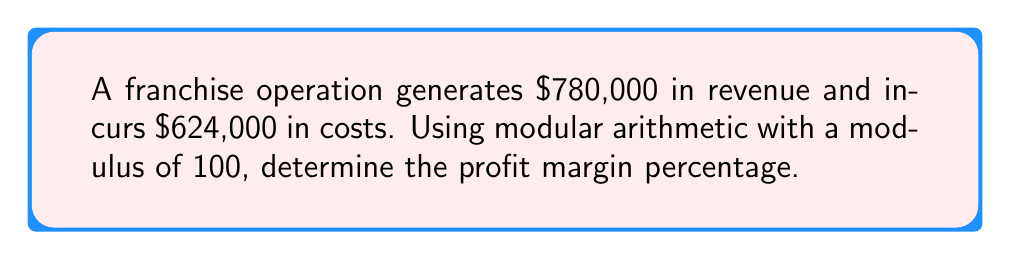What is the answer to this math problem? Let's approach this step-by-step using modular arithmetic:

1) First, calculate the profit:
   Profit = Revenue - Costs
   $780,000 - $624,000 = $156,000

2) The profit margin percentage is calculated as:
   $\text{Profit Margin} = \frac{\text{Profit}}{\text{Revenue}} \times 100\%$

3) Substituting our values:
   $\text{Profit Margin} = \frac{156,000}{780,000} \times 100\%$

4) To use modular arithmetic with modulus 100, we can simplify this fraction:
   $\frac{156,000}{780,000} \equiv \frac{156}{780} \pmod{100}$

5) Simplify the fraction:
   $\frac{156}{780} = \frac{1}{5}$

6) Now, we need to find $\frac{1}{5} \times 100 \pmod{100}$

7) $\frac{1}{5} \times 100 = 20$

8) $20 \pmod{100} \equiv 20$

Therefore, the profit margin percentage is 20%.
Answer: 20% 